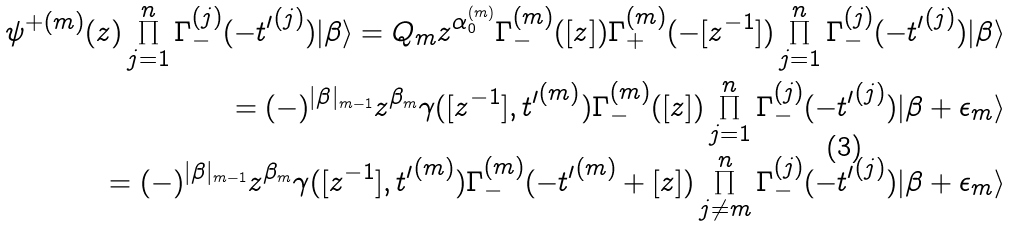<formula> <loc_0><loc_0><loc_500><loc_500>\psi ^ { + ( m ) } ( z ) \prod _ { j = 1 } ^ { n } \Gamma _ { - } ^ { ( j ) } ( - { t ^ { \prime } } ^ { ( j ) } ) | \beta \rangle = Q _ { m } z ^ { \alpha ^ { ( m ) } _ { 0 } } \Gamma _ { - } ^ { ( m ) } ( [ z ] ) \Gamma _ { + } ^ { ( m ) } ( - [ z ^ { - 1 } ] ) \prod _ { j = 1 } ^ { n } \Gamma _ { - } ^ { ( j ) } ( - { t ^ { \prime } } ^ { ( j ) } ) | \beta \rangle \\ = ( - ) ^ { | \beta | _ { m - 1 } } z ^ { \beta _ { m } } \gamma ( [ z ^ { - 1 } ] , { t ^ { \prime } } ^ { ( m ) } ) \Gamma _ { - } ^ { ( m ) } ( [ z ] ) \prod _ { j = 1 } ^ { n } \Gamma _ { - } ^ { ( j ) } ( - { t ^ { \prime } } ^ { ( j ) } ) | \beta + \epsilon _ { m } \rangle \\ = ( - ) ^ { | \beta | _ { m - 1 } } z ^ { \beta _ { m } } \gamma ( [ z ^ { - 1 } ] , { t ^ { \prime } } ^ { ( m ) } ) \Gamma _ { - } ^ { ( m ) } ( - { t ^ { \prime } } ^ { ( m ) } + [ z ] ) \prod _ { j \ne m } ^ { n } \Gamma _ { - } ^ { ( j ) } ( - { t ^ { \prime } } ^ { ( j ) } ) | \beta + \epsilon _ { m } \rangle</formula> 